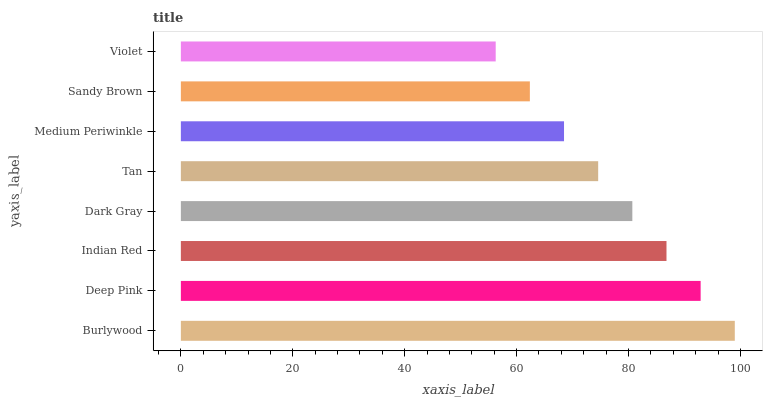Is Violet the minimum?
Answer yes or no. Yes. Is Burlywood the maximum?
Answer yes or no. Yes. Is Deep Pink the minimum?
Answer yes or no. No. Is Deep Pink the maximum?
Answer yes or no. No. Is Burlywood greater than Deep Pink?
Answer yes or no. Yes. Is Deep Pink less than Burlywood?
Answer yes or no. Yes. Is Deep Pink greater than Burlywood?
Answer yes or no. No. Is Burlywood less than Deep Pink?
Answer yes or no. No. Is Dark Gray the high median?
Answer yes or no. Yes. Is Tan the low median?
Answer yes or no. Yes. Is Tan the high median?
Answer yes or no. No. Is Dark Gray the low median?
Answer yes or no. No. 